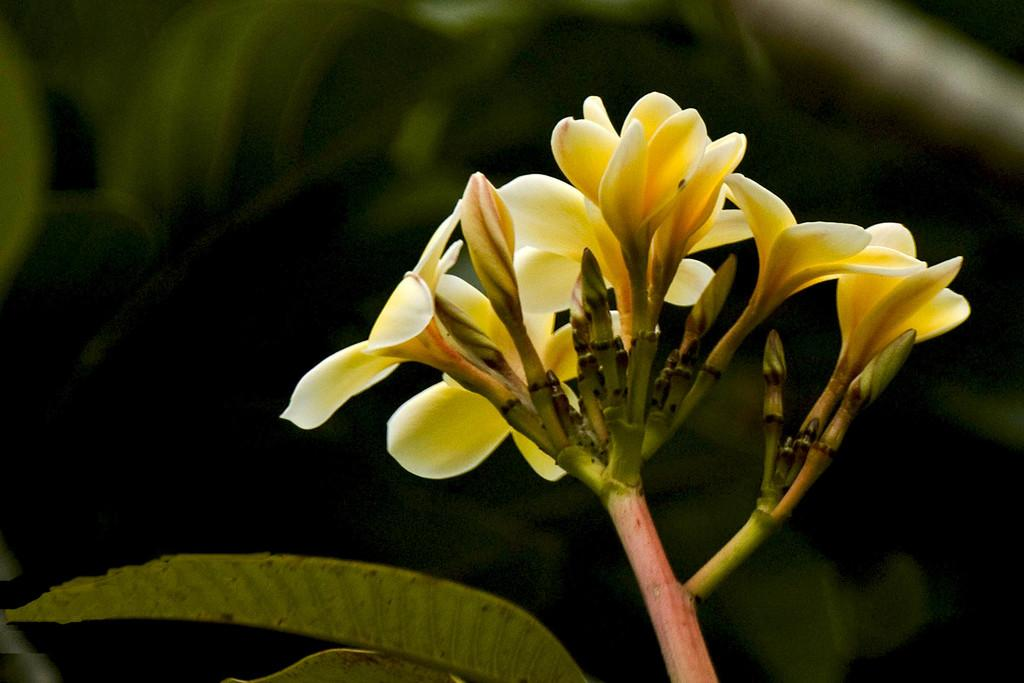What type of plant is visible in the image? There is a part of a plant in the image, which has flowers, buds, and leaves. What are the specific features of the plant that can be seen? The plant has flowers, buds, and leaves. What is the condition of the background in the image? The background of the image is blurred. What type of jam is being spread on the frame in the image? There is no frame or jam present in the image; it features a part of a plant with flowers, buds, and leaves. 